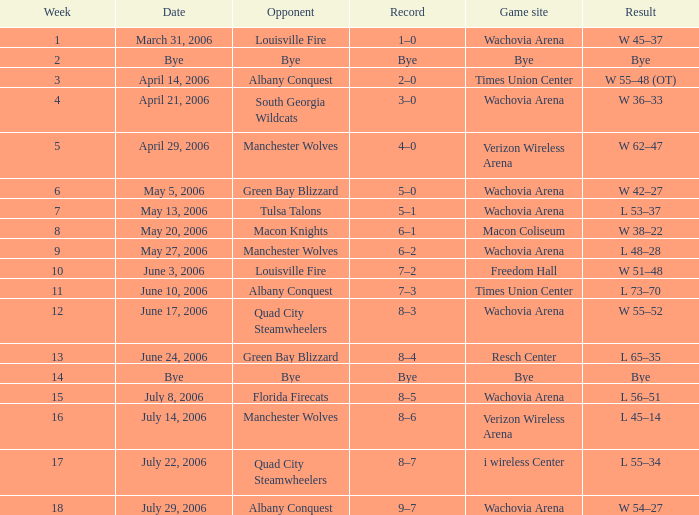What is the result for the game on May 27, 2006? L 48–28. 